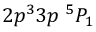Convert formula to latex. <formula><loc_0><loc_0><loc_500><loc_500>{ 2 p ^ { 3 } 3 p ^ { 5 } P _ { 1 } }</formula> 